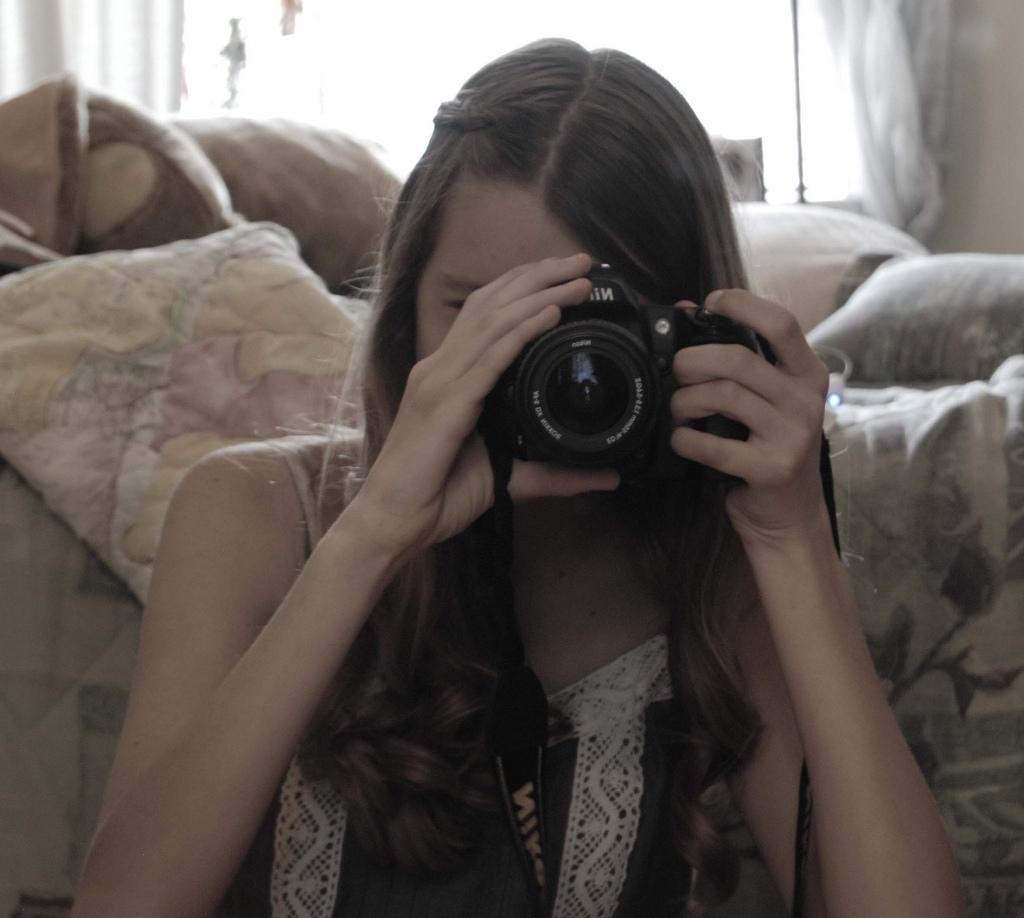Who is the main subject in the image? There is a girl in the image. What is the girl holding in the image? The girl is holding a camera. What can be seen in the background of the image? There is a bed in the background of the image. Can you see any stamps on the girl's forehead in the image? No, there are no stamps visible on the girl's forehead in the image. 